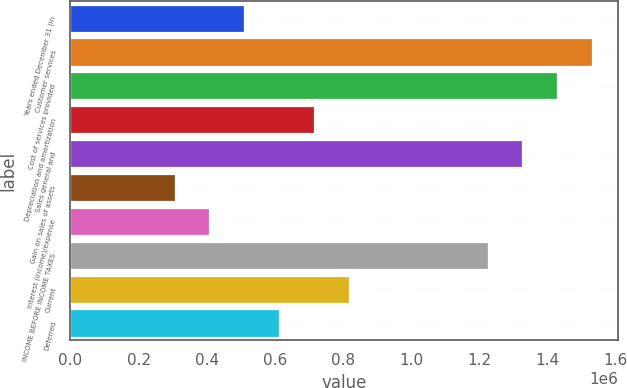Convert chart. <chart><loc_0><loc_0><loc_500><loc_500><bar_chart><fcel>Years ended December 31 (in<fcel>Customer services<fcel>Cost of services provided<fcel>Depreciation and amortization<fcel>Sales general and<fcel>Gain on sales of assets<fcel>Interest (income)/expense<fcel>INCOME BEFORE INCOME TAXES<fcel>Current<fcel>Deferred<nl><fcel>510282<fcel>1.53085e+06<fcel>1.42879e+06<fcel>714395<fcel>1.32673e+06<fcel>306169<fcel>408226<fcel>1.22468e+06<fcel>816451<fcel>612338<nl></chart> 